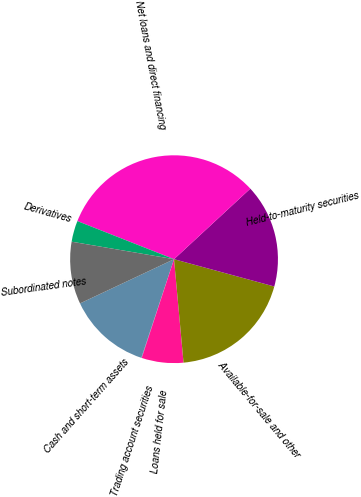<chart> <loc_0><loc_0><loc_500><loc_500><pie_chart><fcel>Cash and short-term assets<fcel>Trading account securities<fcel>Loans held for sale<fcel>Available-for-sale and other<fcel>Held-to-maturity securities<fcel>Net loans and direct financing<fcel>Derivatives<fcel>Subordinated notes<nl><fcel>12.9%<fcel>0.07%<fcel>6.49%<fcel>19.31%<fcel>16.11%<fcel>32.14%<fcel>3.28%<fcel>9.69%<nl></chart> 